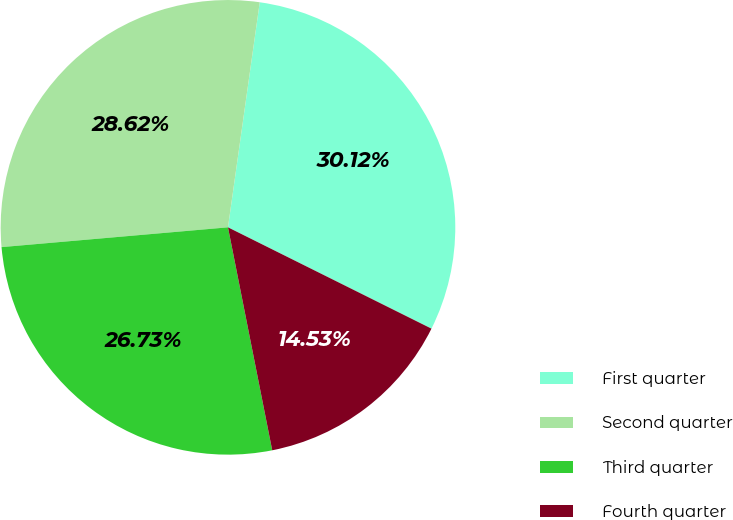Convert chart. <chart><loc_0><loc_0><loc_500><loc_500><pie_chart><fcel>First quarter<fcel>Second quarter<fcel>Third quarter<fcel>Fourth quarter<nl><fcel>30.12%<fcel>28.62%<fcel>26.73%<fcel>14.53%<nl></chart> 